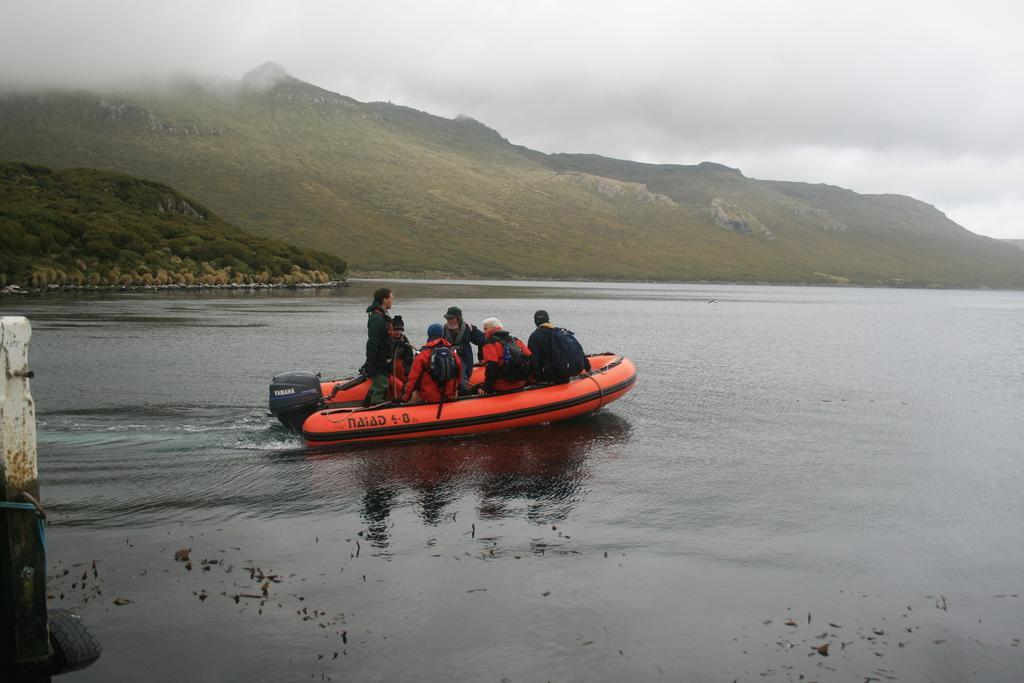Could you give a brief overview of what you see in this image? In this image, we can see a group of people are sailing a boat on the water. Few are wearing backpacks. Left side of the image, we can see a pole, rope, tyre. Background we can see the mountains and trees. 